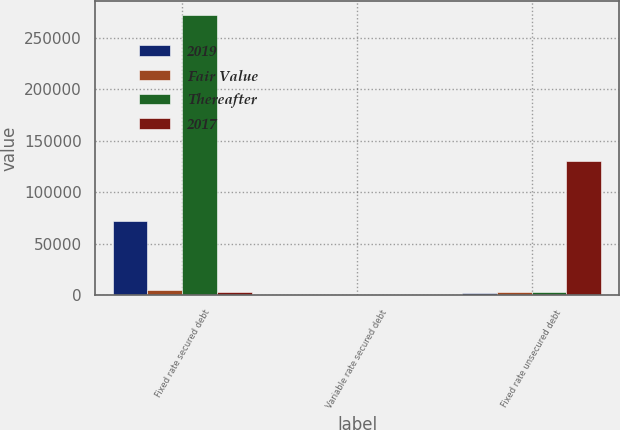<chart> <loc_0><loc_0><loc_500><loc_500><stacked_bar_chart><ecel><fcel>Fixed rate secured debt<fcel>Variable rate secured debt<fcel>Fixed rate unsecured debt<nl><fcel>2019<fcel>72347<fcel>300<fcel>2523<nl><fcel>Fair Value<fcel>4783<fcel>300<fcel>2859<nl><fcel>Thereafter<fcel>272215<fcel>300<fcel>2859<nl><fcel>2017<fcel>3583<fcel>300<fcel>130158<nl></chart> 